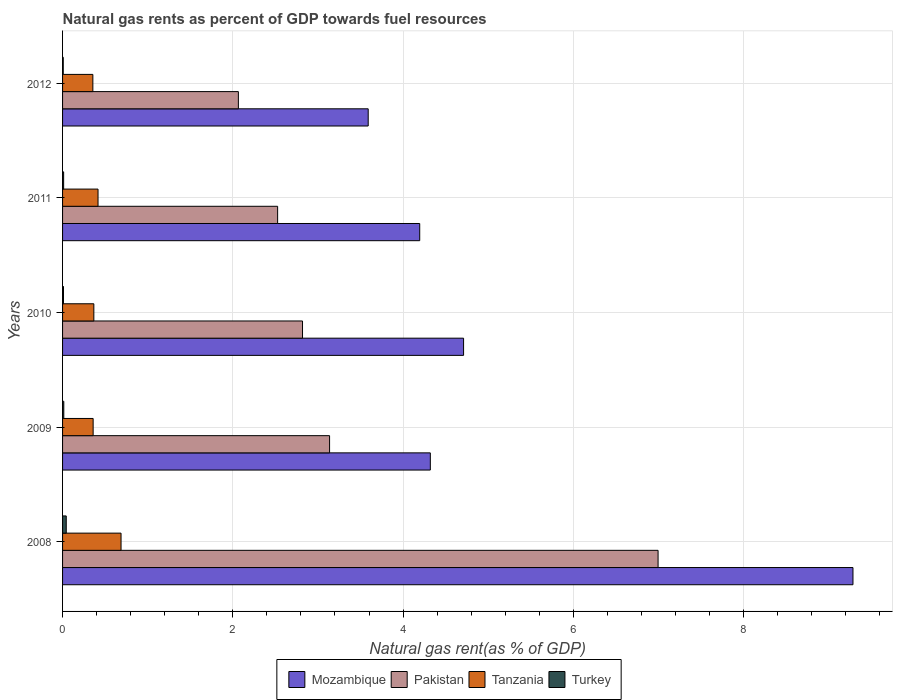Are the number of bars on each tick of the Y-axis equal?
Ensure brevity in your answer.  Yes. What is the natural gas rent in Pakistan in 2012?
Your answer should be very brief. 2.07. Across all years, what is the maximum natural gas rent in Turkey?
Offer a very short reply. 0.04. Across all years, what is the minimum natural gas rent in Tanzania?
Make the answer very short. 0.36. In which year was the natural gas rent in Turkey maximum?
Provide a succinct answer. 2008. What is the total natural gas rent in Mozambique in the graph?
Keep it short and to the point. 26.1. What is the difference between the natural gas rent in Pakistan in 2011 and that in 2012?
Make the answer very short. 0.46. What is the difference between the natural gas rent in Mozambique in 2009 and the natural gas rent in Pakistan in 2011?
Offer a terse response. 1.79. What is the average natural gas rent in Mozambique per year?
Give a very brief answer. 5.22. In the year 2011, what is the difference between the natural gas rent in Tanzania and natural gas rent in Turkey?
Ensure brevity in your answer.  0.4. What is the ratio of the natural gas rent in Tanzania in 2010 to that in 2011?
Your answer should be compact. 0.88. Is the natural gas rent in Mozambique in 2009 less than that in 2012?
Make the answer very short. No. What is the difference between the highest and the second highest natural gas rent in Mozambique?
Your answer should be very brief. 4.57. What is the difference between the highest and the lowest natural gas rent in Pakistan?
Provide a short and direct response. 4.93. In how many years, is the natural gas rent in Tanzania greater than the average natural gas rent in Tanzania taken over all years?
Your answer should be compact. 1. What is the difference between two consecutive major ticks on the X-axis?
Ensure brevity in your answer.  2. Does the graph contain any zero values?
Your response must be concise. No. Where does the legend appear in the graph?
Offer a very short reply. Bottom center. How many legend labels are there?
Your answer should be very brief. 4. What is the title of the graph?
Provide a succinct answer. Natural gas rents as percent of GDP towards fuel resources. What is the label or title of the X-axis?
Offer a terse response. Natural gas rent(as % of GDP). What is the label or title of the Y-axis?
Provide a succinct answer. Years. What is the Natural gas rent(as % of GDP) of Mozambique in 2008?
Make the answer very short. 9.29. What is the Natural gas rent(as % of GDP) of Pakistan in 2008?
Your answer should be compact. 7. What is the Natural gas rent(as % of GDP) of Tanzania in 2008?
Your response must be concise. 0.69. What is the Natural gas rent(as % of GDP) in Turkey in 2008?
Your response must be concise. 0.04. What is the Natural gas rent(as % of GDP) of Mozambique in 2009?
Give a very brief answer. 4.32. What is the Natural gas rent(as % of GDP) of Pakistan in 2009?
Your response must be concise. 3.14. What is the Natural gas rent(as % of GDP) of Tanzania in 2009?
Give a very brief answer. 0.36. What is the Natural gas rent(as % of GDP) in Turkey in 2009?
Offer a terse response. 0.01. What is the Natural gas rent(as % of GDP) of Mozambique in 2010?
Give a very brief answer. 4.71. What is the Natural gas rent(as % of GDP) of Pakistan in 2010?
Offer a terse response. 2.82. What is the Natural gas rent(as % of GDP) of Tanzania in 2010?
Your response must be concise. 0.37. What is the Natural gas rent(as % of GDP) in Turkey in 2010?
Your answer should be very brief. 0.01. What is the Natural gas rent(as % of GDP) of Mozambique in 2011?
Make the answer very short. 4.2. What is the Natural gas rent(as % of GDP) of Pakistan in 2011?
Your answer should be compact. 2.53. What is the Natural gas rent(as % of GDP) in Tanzania in 2011?
Ensure brevity in your answer.  0.42. What is the Natural gas rent(as % of GDP) of Turkey in 2011?
Provide a succinct answer. 0.01. What is the Natural gas rent(as % of GDP) in Mozambique in 2012?
Ensure brevity in your answer.  3.59. What is the Natural gas rent(as % of GDP) in Pakistan in 2012?
Your response must be concise. 2.07. What is the Natural gas rent(as % of GDP) of Tanzania in 2012?
Ensure brevity in your answer.  0.36. What is the Natural gas rent(as % of GDP) in Turkey in 2012?
Your answer should be very brief. 0.01. Across all years, what is the maximum Natural gas rent(as % of GDP) of Mozambique?
Give a very brief answer. 9.29. Across all years, what is the maximum Natural gas rent(as % of GDP) in Pakistan?
Offer a terse response. 7. Across all years, what is the maximum Natural gas rent(as % of GDP) of Tanzania?
Give a very brief answer. 0.69. Across all years, what is the maximum Natural gas rent(as % of GDP) of Turkey?
Give a very brief answer. 0.04. Across all years, what is the minimum Natural gas rent(as % of GDP) of Mozambique?
Offer a very short reply. 3.59. Across all years, what is the minimum Natural gas rent(as % of GDP) in Pakistan?
Give a very brief answer. 2.07. Across all years, what is the minimum Natural gas rent(as % of GDP) in Tanzania?
Offer a very short reply. 0.36. Across all years, what is the minimum Natural gas rent(as % of GDP) in Turkey?
Offer a terse response. 0.01. What is the total Natural gas rent(as % of GDP) in Mozambique in the graph?
Offer a very short reply. 26.1. What is the total Natural gas rent(as % of GDP) of Pakistan in the graph?
Your answer should be compact. 17.54. What is the total Natural gas rent(as % of GDP) in Tanzania in the graph?
Give a very brief answer. 2.19. What is the total Natural gas rent(as % of GDP) of Turkey in the graph?
Give a very brief answer. 0.09. What is the difference between the Natural gas rent(as % of GDP) of Mozambique in 2008 and that in 2009?
Ensure brevity in your answer.  4.96. What is the difference between the Natural gas rent(as % of GDP) of Pakistan in 2008 and that in 2009?
Provide a succinct answer. 3.86. What is the difference between the Natural gas rent(as % of GDP) in Tanzania in 2008 and that in 2009?
Your response must be concise. 0.33. What is the difference between the Natural gas rent(as % of GDP) in Turkey in 2008 and that in 2009?
Provide a succinct answer. 0.03. What is the difference between the Natural gas rent(as % of GDP) in Mozambique in 2008 and that in 2010?
Give a very brief answer. 4.57. What is the difference between the Natural gas rent(as % of GDP) of Pakistan in 2008 and that in 2010?
Offer a very short reply. 4.18. What is the difference between the Natural gas rent(as % of GDP) in Tanzania in 2008 and that in 2010?
Provide a short and direct response. 0.32. What is the difference between the Natural gas rent(as % of GDP) in Turkey in 2008 and that in 2010?
Provide a short and direct response. 0.03. What is the difference between the Natural gas rent(as % of GDP) of Mozambique in 2008 and that in 2011?
Give a very brief answer. 5.09. What is the difference between the Natural gas rent(as % of GDP) of Pakistan in 2008 and that in 2011?
Keep it short and to the point. 4.47. What is the difference between the Natural gas rent(as % of GDP) in Tanzania in 2008 and that in 2011?
Provide a succinct answer. 0.27. What is the difference between the Natural gas rent(as % of GDP) of Turkey in 2008 and that in 2011?
Offer a terse response. 0.03. What is the difference between the Natural gas rent(as % of GDP) of Mozambique in 2008 and that in 2012?
Offer a very short reply. 5.69. What is the difference between the Natural gas rent(as % of GDP) of Pakistan in 2008 and that in 2012?
Ensure brevity in your answer.  4.93. What is the difference between the Natural gas rent(as % of GDP) in Tanzania in 2008 and that in 2012?
Keep it short and to the point. 0.33. What is the difference between the Natural gas rent(as % of GDP) in Turkey in 2008 and that in 2012?
Ensure brevity in your answer.  0.04. What is the difference between the Natural gas rent(as % of GDP) in Mozambique in 2009 and that in 2010?
Offer a terse response. -0.39. What is the difference between the Natural gas rent(as % of GDP) in Pakistan in 2009 and that in 2010?
Give a very brief answer. 0.32. What is the difference between the Natural gas rent(as % of GDP) of Tanzania in 2009 and that in 2010?
Provide a succinct answer. -0.01. What is the difference between the Natural gas rent(as % of GDP) of Turkey in 2009 and that in 2010?
Ensure brevity in your answer.  0. What is the difference between the Natural gas rent(as % of GDP) in Mozambique in 2009 and that in 2011?
Ensure brevity in your answer.  0.12. What is the difference between the Natural gas rent(as % of GDP) in Pakistan in 2009 and that in 2011?
Ensure brevity in your answer.  0.61. What is the difference between the Natural gas rent(as % of GDP) in Tanzania in 2009 and that in 2011?
Provide a short and direct response. -0.06. What is the difference between the Natural gas rent(as % of GDP) of Turkey in 2009 and that in 2011?
Provide a succinct answer. 0. What is the difference between the Natural gas rent(as % of GDP) in Mozambique in 2009 and that in 2012?
Offer a very short reply. 0.73. What is the difference between the Natural gas rent(as % of GDP) of Pakistan in 2009 and that in 2012?
Give a very brief answer. 1.07. What is the difference between the Natural gas rent(as % of GDP) of Tanzania in 2009 and that in 2012?
Your answer should be compact. 0. What is the difference between the Natural gas rent(as % of GDP) in Turkey in 2009 and that in 2012?
Your answer should be very brief. 0.01. What is the difference between the Natural gas rent(as % of GDP) of Mozambique in 2010 and that in 2011?
Give a very brief answer. 0.52. What is the difference between the Natural gas rent(as % of GDP) in Pakistan in 2010 and that in 2011?
Your answer should be compact. 0.29. What is the difference between the Natural gas rent(as % of GDP) in Tanzania in 2010 and that in 2011?
Your response must be concise. -0.05. What is the difference between the Natural gas rent(as % of GDP) of Turkey in 2010 and that in 2011?
Keep it short and to the point. -0. What is the difference between the Natural gas rent(as % of GDP) in Mozambique in 2010 and that in 2012?
Keep it short and to the point. 1.12. What is the difference between the Natural gas rent(as % of GDP) of Pakistan in 2010 and that in 2012?
Give a very brief answer. 0.75. What is the difference between the Natural gas rent(as % of GDP) in Tanzania in 2010 and that in 2012?
Your answer should be very brief. 0.01. What is the difference between the Natural gas rent(as % of GDP) in Turkey in 2010 and that in 2012?
Your answer should be very brief. 0. What is the difference between the Natural gas rent(as % of GDP) in Mozambique in 2011 and that in 2012?
Provide a short and direct response. 0.61. What is the difference between the Natural gas rent(as % of GDP) of Pakistan in 2011 and that in 2012?
Give a very brief answer. 0.46. What is the difference between the Natural gas rent(as % of GDP) of Tanzania in 2011 and that in 2012?
Your response must be concise. 0.06. What is the difference between the Natural gas rent(as % of GDP) of Turkey in 2011 and that in 2012?
Your response must be concise. 0. What is the difference between the Natural gas rent(as % of GDP) of Mozambique in 2008 and the Natural gas rent(as % of GDP) of Pakistan in 2009?
Keep it short and to the point. 6.15. What is the difference between the Natural gas rent(as % of GDP) in Mozambique in 2008 and the Natural gas rent(as % of GDP) in Tanzania in 2009?
Provide a short and direct response. 8.93. What is the difference between the Natural gas rent(as % of GDP) in Mozambique in 2008 and the Natural gas rent(as % of GDP) in Turkey in 2009?
Provide a succinct answer. 9.27. What is the difference between the Natural gas rent(as % of GDP) of Pakistan in 2008 and the Natural gas rent(as % of GDP) of Tanzania in 2009?
Make the answer very short. 6.64. What is the difference between the Natural gas rent(as % of GDP) in Pakistan in 2008 and the Natural gas rent(as % of GDP) in Turkey in 2009?
Provide a short and direct response. 6.98. What is the difference between the Natural gas rent(as % of GDP) of Tanzania in 2008 and the Natural gas rent(as % of GDP) of Turkey in 2009?
Your answer should be compact. 0.67. What is the difference between the Natural gas rent(as % of GDP) of Mozambique in 2008 and the Natural gas rent(as % of GDP) of Pakistan in 2010?
Give a very brief answer. 6.47. What is the difference between the Natural gas rent(as % of GDP) in Mozambique in 2008 and the Natural gas rent(as % of GDP) in Tanzania in 2010?
Keep it short and to the point. 8.92. What is the difference between the Natural gas rent(as % of GDP) in Mozambique in 2008 and the Natural gas rent(as % of GDP) in Turkey in 2010?
Offer a very short reply. 9.27. What is the difference between the Natural gas rent(as % of GDP) in Pakistan in 2008 and the Natural gas rent(as % of GDP) in Tanzania in 2010?
Provide a succinct answer. 6.63. What is the difference between the Natural gas rent(as % of GDP) in Pakistan in 2008 and the Natural gas rent(as % of GDP) in Turkey in 2010?
Ensure brevity in your answer.  6.98. What is the difference between the Natural gas rent(as % of GDP) of Tanzania in 2008 and the Natural gas rent(as % of GDP) of Turkey in 2010?
Keep it short and to the point. 0.68. What is the difference between the Natural gas rent(as % of GDP) of Mozambique in 2008 and the Natural gas rent(as % of GDP) of Pakistan in 2011?
Make the answer very short. 6.76. What is the difference between the Natural gas rent(as % of GDP) in Mozambique in 2008 and the Natural gas rent(as % of GDP) in Tanzania in 2011?
Your answer should be very brief. 8.87. What is the difference between the Natural gas rent(as % of GDP) of Mozambique in 2008 and the Natural gas rent(as % of GDP) of Turkey in 2011?
Make the answer very short. 9.27. What is the difference between the Natural gas rent(as % of GDP) of Pakistan in 2008 and the Natural gas rent(as % of GDP) of Tanzania in 2011?
Your response must be concise. 6.58. What is the difference between the Natural gas rent(as % of GDP) of Pakistan in 2008 and the Natural gas rent(as % of GDP) of Turkey in 2011?
Provide a succinct answer. 6.98. What is the difference between the Natural gas rent(as % of GDP) of Tanzania in 2008 and the Natural gas rent(as % of GDP) of Turkey in 2011?
Ensure brevity in your answer.  0.67. What is the difference between the Natural gas rent(as % of GDP) of Mozambique in 2008 and the Natural gas rent(as % of GDP) of Pakistan in 2012?
Your answer should be compact. 7.22. What is the difference between the Natural gas rent(as % of GDP) of Mozambique in 2008 and the Natural gas rent(as % of GDP) of Tanzania in 2012?
Keep it short and to the point. 8.93. What is the difference between the Natural gas rent(as % of GDP) of Mozambique in 2008 and the Natural gas rent(as % of GDP) of Turkey in 2012?
Your response must be concise. 9.28. What is the difference between the Natural gas rent(as % of GDP) of Pakistan in 2008 and the Natural gas rent(as % of GDP) of Tanzania in 2012?
Provide a short and direct response. 6.64. What is the difference between the Natural gas rent(as % of GDP) of Pakistan in 2008 and the Natural gas rent(as % of GDP) of Turkey in 2012?
Make the answer very short. 6.99. What is the difference between the Natural gas rent(as % of GDP) of Tanzania in 2008 and the Natural gas rent(as % of GDP) of Turkey in 2012?
Offer a terse response. 0.68. What is the difference between the Natural gas rent(as % of GDP) in Mozambique in 2009 and the Natural gas rent(as % of GDP) in Pakistan in 2010?
Provide a succinct answer. 1.5. What is the difference between the Natural gas rent(as % of GDP) of Mozambique in 2009 and the Natural gas rent(as % of GDP) of Tanzania in 2010?
Give a very brief answer. 3.95. What is the difference between the Natural gas rent(as % of GDP) of Mozambique in 2009 and the Natural gas rent(as % of GDP) of Turkey in 2010?
Make the answer very short. 4.31. What is the difference between the Natural gas rent(as % of GDP) in Pakistan in 2009 and the Natural gas rent(as % of GDP) in Tanzania in 2010?
Provide a succinct answer. 2.77. What is the difference between the Natural gas rent(as % of GDP) of Pakistan in 2009 and the Natural gas rent(as % of GDP) of Turkey in 2010?
Ensure brevity in your answer.  3.13. What is the difference between the Natural gas rent(as % of GDP) of Tanzania in 2009 and the Natural gas rent(as % of GDP) of Turkey in 2010?
Your answer should be compact. 0.35. What is the difference between the Natural gas rent(as % of GDP) in Mozambique in 2009 and the Natural gas rent(as % of GDP) in Pakistan in 2011?
Give a very brief answer. 1.79. What is the difference between the Natural gas rent(as % of GDP) of Mozambique in 2009 and the Natural gas rent(as % of GDP) of Tanzania in 2011?
Give a very brief answer. 3.9. What is the difference between the Natural gas rent(as % of GDP) in Mozambique in 2009 and the Natural gas rent(as % of GDP) in Turkey in 2011?
Offer a very short reply. 4.31. What is the difference between the Natural gas rent(as % of GDP) of Pakistan in 2009 and the Natural gas rent(as % of GDP) of Tanzania in 2011?
Your answer should be very brief. 2.72. What is the difference between the Natural gas rent(as % of GDP) in Pakistan in 2009 and the Natural gas rent(as % of GDP) in Turkey in 2011?
Provide a short and direct response. 3.12. What is the difference between the Natural gas rent(as % of GDP) of Tanzania in 2009 and the Natural gas rent(as % of GDP) of Turkey in 2011?
Provide a short and direct response. 0.35. What is the difference between the Natural gas rent(as % of GDP) in Mozambique in 2009 and the Natural gas rent(as % of GDP) in Pakistan in 2012?
Keep it short and to the point. 2.25. What is the difference between the Natural gas rent(as % of GDP) of Mozambique in 2009 and the Natural gas rent(as % of GDP) of Tanzania in 2012?
Your answer should be compact. 3.96. What is the difference between the Natural gas rent(as % of GDP) in Mozambique in 2009 and the Natural gas rent(as % of GDP) in Turkey in 2012?
Ensure brevity in your answer.  4.31. What is the difference between the Natural gas rent(as % of GDP) in Pakistan in 2009 and the Natural gas rent(as % of GDP) in Tanzania in 2012?
Your response must be concise. 2.78. What is the difference between the Natural gas rent(as % of GDP) in Pakistan in 2009 and the Natural gas rent(as % of GDP) in Turkey in 2012?
Make the answer very short. 3.13. What is the difference between the Natural gas rent(as % of GDP) in Tanzania in 2009 and the Natural gas rent(as % of GDP) in Turkey in 2012?
Offer a terse response. 0.35. What is the difference between the Natural gas rent(as % of GDP) in Mozambique in 2010 and the Natural gas rent(as % of GDP) in Pakistan in 2011?
Provide a succinct answer. 2.18. What is the difference between the Natural gas rent(as % of GDP) of Mozambique in 2010 and the Natural gas rent(as % of GDP) of Tanzania in 2011?
Offer a terse response. 4.29. What is the difference between the Natural gas rent(as % of GDP) of Mozambique in 2010 and the Natural gas rent(as % of GDP) of Turkey in 2011?
Your answer should be compact. 4.7. What is the difference between the Natural gas rent(as % of GDP) of Pakistan in 2010 and the Natural gas rent(as % of GDP) of Tanzania in 2011?
Provide a succinct answer. 2.4. What is the difference between the Natural gas rent(as % of GDP) in Pakistan in 2010 and the Natural gas rent(as % of GDP) in Turkey in 2011?
Give a very brief answer. 2.81. What is the difference between the Natural gas rent(as % of GDP) in Tanzania in 2010 and the Natural gas rent(as % of GDP) in Turkey in 2011?
Keep it short and to the point. 0.35. What is the difference between the Natural gas rent(as % of GDP) of Mozambique in 2010 and the Natural gas rent(as % of GDP) of Pakistan in 2012?
Provide a short and direct response. 2.65. What is the difference between the Natural gas rent(as % of GDP) in Mozambique in 2010 and the Natural gas rent(as % of GDP) in Tanzania in 2012?
Your answer should be compact. 4.36. What is the difference between the Natural gas rent(as % of GDP) of Mozambique in 2010 and the Natural gas rent(as % of GDP) of Turkey in 2012?
Give a very brief answer. 4.7. What is the difference between the Natural gas rent(as % of GDP) in Pakistan in 2010 and the Natural gas rent(as % of GDP) in Tanzania in 2012?
Make the answer very short. 2.46. What is the difference between the Natural gas rent(as % of GDP) of Pakistan in 2010 and the Natural gas rent(as % of GDP) of Turkey in 2012?
Your response must be concise. 2.81. What is the difference between the Natural gas rent(as % of GDP) in Tanzania in 2010 and the Natural gas rent(as % of GDP) in Turkey in 2012?
Offer a very short reply. 0.36. What is the difference between the Natural gas rent(as % of GDP) in Mozambique in 2011 and the Natural gas rent(as % of GDP) in Pakistan in 2012?
Provide a short and direct response. 2.13. What is the difference between the Natural gas rent(as % of GDP) in Mozambique in 2011 and the Natural gas rent(as % of GDP) in Tanzania in 2012?
Offer a very short reply. 3.84. What is the difference between the Natural gas rent(as % of GDP) in Mozambique in 2011 and the Natural gas rent(as % of GDP) in Turkey in 2012?
Your response must be concise. 4.19. What is the difference between the Natural gas rent(as % of GDP) in Pakistan in 2011 and the Natural gas rent(as % of GDP) in Tanzania in 2012?
Offer a very short reply. 2.17. What is the difference between the Natural gas rent(as % of GDP) of Pakistan in 2011 and the Natural gas rent(as % of GDP) of Turkey in 2012?
Offer a very short reply. 2.52. What is the difference between the Natural gas rent(as % of GDP) of Tanzania in 2011 and the Natural gas rent(as % of GDP) of Turkey in 2012?
Make the answer very short. 0.41. What is the average Natural gas rent(as % of GDP) in Mozambique per year?
Provide a short and direct response. 5.22. What is the average Natural gas rent(as % of GDP) of Pakistan per year?
Your response must be concise. 3.51. What is the average Natural gas rent(as % of GDP) of Tanzania per year?
Your answer should be compact. 0.44. What is the average Natural gas rent(as % of GDP) of Turkey per year?
Offer a very short reply. 0.02. In the year 2008, what is the difference between the Natural gas rent(as % of GDP) of Mozambique and Natural gas rent(as % of GDP) of Pakistan?
Offer a very short reply. 2.29. In the year 2008, what is the difference between the Natural gas rent(as % of GDP) in Mozambique and Natural gas rent(as % of GDP) in Tanzania?
Provide a succinct answer. 8.6. In the year 2008, what is the difference between the Natural gas rent(as % of GDP) of Mozambique and Natural gas rent(as % of GDP) of Turkey?
Provide a succinct answer. 9.24. In the year 2008, what is the difference between the Natural gas rent(as % of GDP) in Pakistan and Natural gas rent(as % of GDP) in Tanzania?
Keep it short and to the point. 6.31. In the year 2008, what is the difference between the Natural gas rent(as % of GDP) in Pakistan and Natural gas rent(as % of GDP) in Turkey?
Offer a terse response. 6.95. In the year 2008, what is the difference between the Natural gas rent(as % of GDP) of Tanzania and Natural gas rent(as % of GDP) of Turkey?
Provide a succinct answer. 0.64. In the year 2009, what is the difference between the Natural gas rent(as % of GDP) of Mozambique and Natural gas rent(as % of GDP) of Pakistan?
Ensure brevity in your answer.  1.18. In the year 2009, what is the difference between the Natural gas rent(as % of GDP) of Mozambique and Natural gas rent(as % of GDP) of Tanzania?
Make the answer very short. 3.96. In the year 2009, what is the difference between the Natural gas rent(as % of GDP) in Mozambique and Natural gas rent(as % of GDP) in Turkey?
Your answer should be compact. 4.31. In the year 2009, what is the difference between the Natural gas rent(as % of GDP) of Pakistan and Natural gas rent(as % of GDP) of Tanzania?
Your response must be concise. 2.78. In the year 2009, what is the difference between the Natural gas rent(as % of GDP) of Pakistan and Natural gas rent(as % of GDP) of Turkey?
Your response must be concise. 3.12. In the year 2009, what is the difference between the Natural gas rent(as % of GDP) in Tanzania and Natural gas rent(as % of GDP) in Turkey?
Your answer should be compact. 0.34. In the year 2010, what is the difference between the Natural gas rent(as % of GDP) of Mozambique and Natural gas rent(as % of GDP) of Pakistan?
Provide a succinct answer. 1.89. In the year 2010, what is the difference between the Natural gas rent(as % of GDP) of Mozambique and Natural gas rent(as % of GDP) of Tanzania?
Offer a terse response. 4.34. In the year 2010, what is the difference between the Natural gas rent(as % of GDP) of Mozambique and Natural gas rent(as % of GDP) of Turkey?
Make the answer very short. 4.7. In the year 2010, what is the difference between the Natural gas rent(as % of GDP) of Pakistan and Natural gas rent(as % of GDP) of Tanzania?
Give a very brief answer. 2.45. In the year 2010, what is the difference between the Natural gas rent(as % of GDP) of Pakistan and Natural gas rent(as % of GDP) of Turkey?
Provide a succinct answer. 2.81. In the year 2010, what is the difference between the Natural gas rent(as % of GDP) of Tanzania and Natural gas rent(as % of GDP) of Turkey?
Offer a terse response. 0.36. In the year 2011, what is the difference between the Natural gas rent(as % of GDP) in Mozambique and Natural gas rent(as % of GDP) in Pakistan?
Provide a short and direct response. 1.67. In the year 2011, what is the difference between the Natural gas rent(as % of GDP) of Mozambique and Natural gas rent(as % of GDP) of Tanzania?
Your answer should be very brief. 3.78. In the year 2011, what is the difference between the Natural gas rent(as % of GDP) in Mozambique and Natural gas rent(as % of GDP) in Turkey?
Give a very brief answer. 4.18. In the year 2011, what is the difference between the Natural gas rent(as % of GDP) of Pakistan and Natural gas rent(as % of GDP) of Tanzania?
Your answer should be very brief. 2.11. In the year 2011, what is the difference between the Natural gas rent(as % of GDP) in Pakistan and Natural gas rent(as % of GDP) in Turkey?
Your response must be concise. 2.51. In the year 2011, what is the difference between the Natural gas rent(as % of GDP) in Tanzania and Natural gas rent(as % of GDP) in Turkey?
Provide a short and direct response. 0.4. In the year 2012, what is the difference between the Natural gas rent(as % of GDP) of Mozambique and Natural gas rent(as % of GDP) of Pakistan?
Offer a very short reply. 1.53. In the year 2012, what is the difference between the Natural gas rent(as % of GDP) of Mozambique and Natural gas rent(as % of GDP) of Tanzania?
Offer a very short reply. 3.23. In the year 2012, what is the difference between the Natural gas rent(as % of GDP) of Mozambique and Natural gas rent(as % of GDP) of Turkey?
Provide a succinct answer. 3.58. In the year 2012, what is the difference between the Natural gas rent(as % of GDP) in Pakistan and Natural gas rent(as % of GDP) in Tanzania?
Offer a very short reply. 1.71. In the year 2012, what is the difference between the Natural gas rent(as % of GDP) in Pakistan and Natural gas rent(as % of GDP) in Turkey?
Provide a short and direct response. 2.06. In the year 2012, what is the difference between the Natural gas rent(as % of GDP) in Tanzania and Natural gas rent(as % of GDP) in Turkey?
Your answer should be very brief. 0.35. What is the ratio of the Natural gas rent(as % of GDP) of Mozambique in 2008 to that in 2009?
Your response must be concise. 2.15. What is the ratio of the Natural gas rent(as % of GDP) in Pakistan in 2008 to that in 2009?
Offer a very short reply. 2.23. What is the ratio of the Natural gas rent(as % of GDP) of Tanzania in 2008 to that in 2009?
Offer a very short reply. 1.91. What is the ratio of the Natural gas rent(as % of GDP) of Turkey in 2008 to that in 2009?
Your answer should be very brief. 2.99. What is the ratio of the Natural gas rent(as % of GDP) in Mozambique in 2008 to that in 2010?
Your response must be concise. 1.97. What is the ratio of the Natural gas rent(as % of GDP) of Pakistan in 2008 to that in 2010?
Ensure brevity in your answer.  2.48. What is the ratio of the Natural gas rent(as % of GDP) in Tanzania in 2008 to that in 2010?
Provide a short and direct response. 1.87. What is the ratio of the Natural gas rent(as % of GDP) of Turkey in 2008 to that in 2010?
Your response must be concise. 3.93. What is the ratio of the Natural gas rent(as % of GDP) in Mozambique in 2008 to that in 2011?
Your response must be concise. 2.21. What is the ratio of the Natural gas rent(as % of GDP) in Pakistan in 2008 to that in 2011?
Provide a succinct answer. 2.77. What is the ratio of the Natural gas rent(as % of GDP) in Tanzania in 2008 to that in 2011?
Provide a short and direct response. 1.65. What is the ratio of the Natural gas rent(as % of GDP) in Turkey in 2008 to that in 2011?
Offer a very short reply. 3.44. What is the ratio of the Natural gas rent(as % of GDP) of Mozambique in 2008 to that in 2012?
Your response must be concise. 2.59. What is the ratio of the Natural gas rent(as % of GDP) in Pakistan in 2008 to that in 2012?
Offer a terse response. 3.39. What is the ratio of the Natural gas rent(as % of GDP) of Tanzania in 2008 to that in 2012?
Ensure brevity in your answer.  1.93. What is the ratio of the Natural gas rent(as % of GDP) of Turkey in 2008 to that in 2012?
Make the answer very short. 5.34. What is the ratio of the Natural gas rent(as % of GDP) in Mozambique in 2009 to that in 2010?
Give a very brief answer. 0.92. What is the ratio of the Natural gas rent(as % of GDP) of Pakistan in 2009 to that in 2010?
Keep it short and to the point. 1.11. What is the ratio of the Natural gas rent(as % of GDP) of Tanzania in 2009 to that in 2010?
Provide a short and direct response. 0.98. What is the ratio of the Natural gas rent(as % of GDP) of Turkey in 2009 to that in 2010?
Your answer should be very brief. 1.31. What is the ratio of the Natural gas rent(as % of GDP) of Mozambique in 2009 to that in 2011?
Provide a short and direct response. 1.03. What is the ratio of the Natural gas rent(as % of GDP) in Pakistan in 2009 to that in 2011?
Offer a terse response. 1.24. What is the ratio of the Natural gas rent(as % of GDP) in Tanzania in 2009 to that in 2011?
Your response must be concise. 0.86. What is the ratio of the Natural gas rent(as % of GDP) in Turkey in 2009 to that in 2011?
Make the answer very short. 1.15. What is the ratio of the Natural gas rent(as % of GDP) of Mozambique in 2009 to that in 2012?
Ensure brevity in your answer.  1.2. What is the ratio of the Natural gas rent(as % of GDP) of Pakistan in 2009 to that in 2012?
Keep it short and to the point. 1.52. What is the ratio of the Natural gas rent(as % of GDP) in Tanzania in 2009 to that in 2012?
Provide a succinct answer. 1.01. What is the ratio of the Natural gas rent(as % of GDP) of Turkey in 2009 to that in 2012?
Ensure brevity in your answer.  1.79. What is the ratio of the Natural gas rent(as % of GDP) in Mozambique in 2010 to that in 2011?
Your answer should be very brief. 1.12. What is the ratio of the Natural gas rent(as % of GDP) of Pakistan in 2010 to that in 2011?
Offer a terse response. 1.12. What is the ratio of the Natural gas rent(as % of GDP) in Tanzania in 2010 to that in 2011?
Your answer should be compact. 0.88. What is the ratio of the Natural gas rent(as % of GDP) in Turkey in 2010 to that in 2011?
Provide a succinct answer. 0.88. What is the ratio of the Natural gas rent(as % of GDP) of Mozambique in 2010 to that in 2012?
Offer a very short reply. 1.31. What is the ratio of the Natural gas rent(as % of GDP) of Pakistan in 2010 to that in 2012?
Make the answer very short. 1.36. What is the ratio of the Natural gas rent(as % of GDP) in Tanzania in 2010 to that in 2012?
Your answer should be very brief. 1.03. What is the ratio of the Natural gas rent(as % of GDP) of Turkey in 2010 to that in 2012?
Your response must be concise. 1.36. What is the ratio of the Natural gas rent(as % of GDP) of Mozambique in 2011 to that in 2012?
Provide a succinct answer. 1.17. What is the ratio of the Natural gas rent(as % of GDP) in Pakistan in 2011 to that in 2012?
Your answer should be compact. 1.22. What is the ratio of the Natural gas rent(as % of GDP) in Tanzania in 2011 to that in 2012?
Make the answer very short. 1.17. What is the ratio of the Natural gas rent(as % of GDP) of Turkey in 2011 to that in 2012?
Your answer should be very brief. 1.55. What is the difference between the highest and the second highest Natural gas rent(as % of GDP) in Mozambique?
Offer a very short reply. 4.57. What is the difference between the highest and the second highest Natural gas rent(as % of GDP) of Pakistan?
Your answer should be very brief. 3.86. What is the difference between the highest and the second highest Natural gas rent(as % of GDP) in Tanzania?
Your answer should be very brief. 0.27. What is the difference between the highest and the second highest Natural gas rent(as % of GDP) in Turkey?
Your response must be concise. 0.03. What is the difference between the highest and the lowest Natural gas rent(as % of GDP) in Mozambique?
Ensure brevity in your answer.  5.69. What is the difference between the highest and the lowest Natural gas rent(as % of GDP) in Pakistan?
Keep it short and to the point. 4.93. What is the difference between the highest and the lowest Natural gas rent(as % of GDP) of Tanzania?
Provide a short and direct response. 0.33. What is the difference between the highest and the lowest Natural gas rent(as % of GDP) of Turkey?
Offer a terse response. 0.04. 